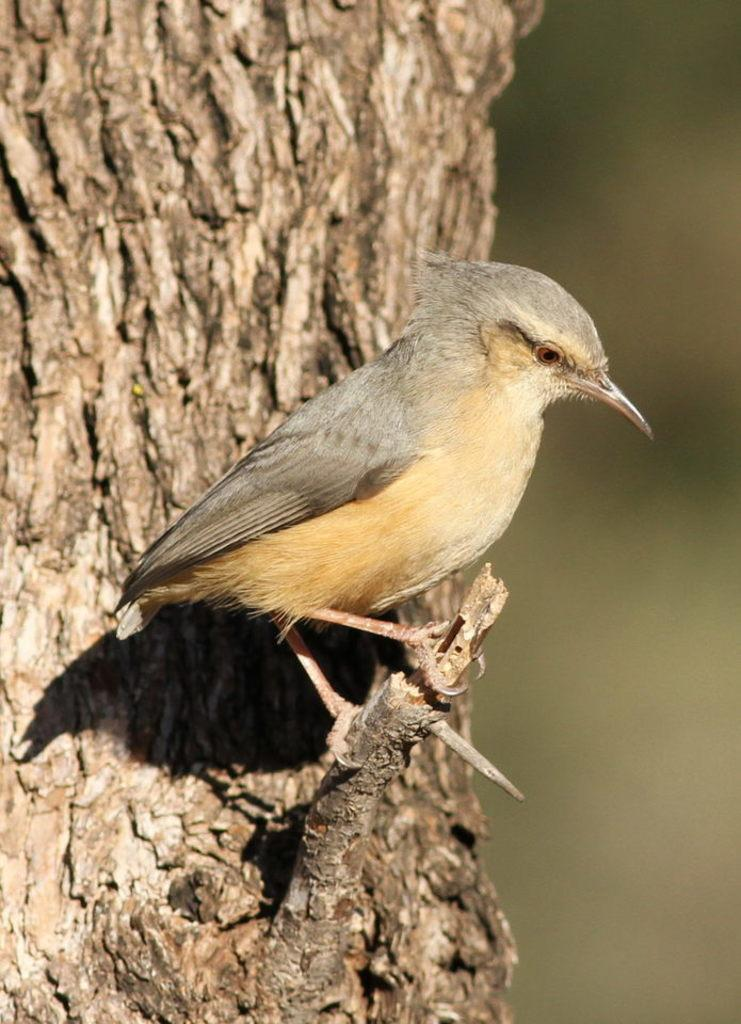What type of animal can be seen in the image? There is a bird in the image. What part of a tree is visible in the image? The trunk of a tree is visible in the image. What type of salt is being used to create the paste for the bird's humor in the image? There is no salt, paste, or humor involving the bird in the image. The bird is simply perched on a tree trunk. 